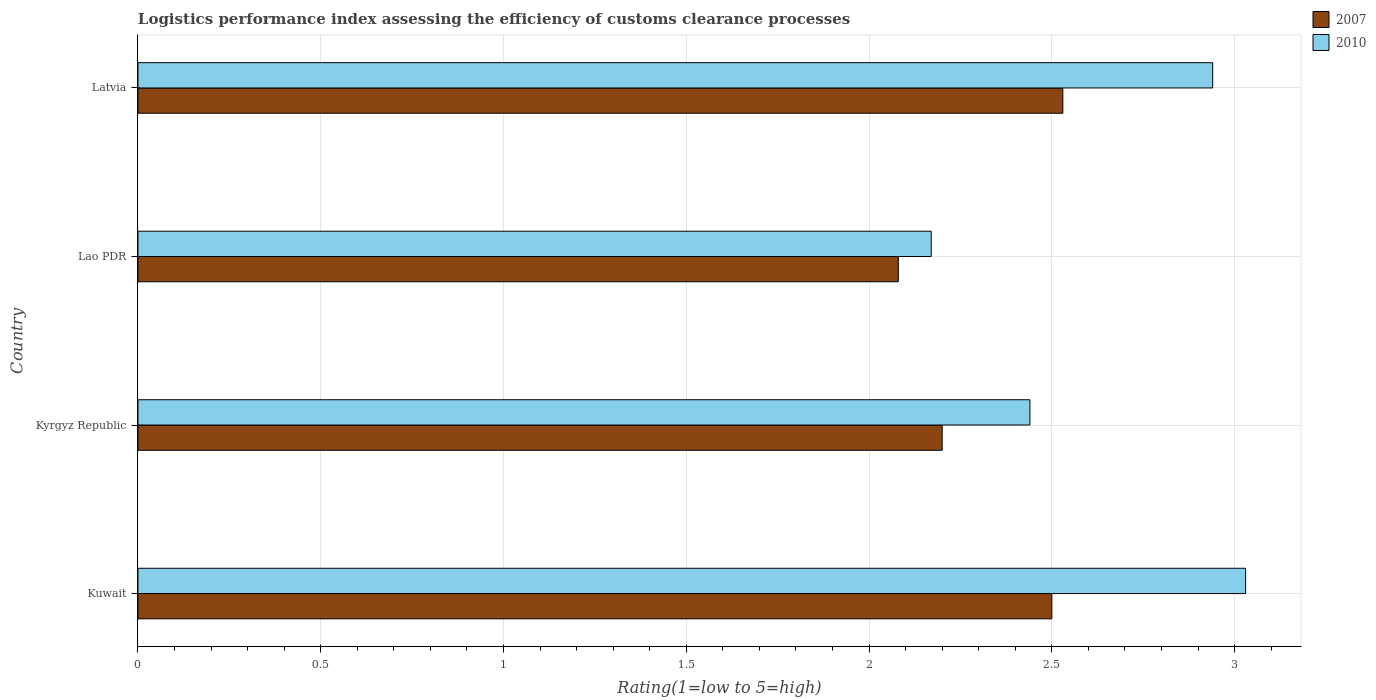How many groups of bars are there?
Offer a very short reply. 4. What is the label of the 4th group of bars from the top?
Make the answer very short. Kuwait. In how many cases, is the number of bars for a given country not equal to the number of legend labels?
Provide a short and direct response. 0. What is the Logistic performance index in 2010 in Kyrgyz Republic?
Your response must be concise. 2.44. Across all countries, what is the maximum Logistic performance index in 2007?
Ensure brevity in your answer.  2.53. Across all countries, what is the minimum Logistic performance index in 2010?
Offer a very short reply. 2.17. In which country was the Logistic performance index in 2010 maximum?
Offer a terse response. Kuwait. In which country was the Logistic performance index in 2007 minimum?
Your response must be concise. Lao PDR. What is the total Logistic performance index in 2007 in the graph?
Make the answer very short. 9.31. What is the difference between the Logistic performance index in 2007 in Lao PDR and that in Latvia?
Offer a very short reply. -0.45. What is the difference between the Logistic performance index in 2010 in Kyrgyz Republic and the Logistic performance index in 2007 in Lao PDR?
Give a very brief answer. 0.36. What is the average Logistic performance index in 2007 per country?
Your response must be concise. 2.33. What is the difference between the Logistic performance index in 2010 and Logistic performance index in 2007 in Kyrgyz Republic?
Offer a very short reply. 0.24. What is the ratio of the Logistic performance index in 2007 in Kyrgyz Republic to that in Latvia?
Your answer should be compact. 0.87. Is the Logistic performance index in 2010 in Kuwait less than that in Kyrgyz Republic?
Offer a very short reply. No. Is the difference between the Logistic performance index in 2010 in Kuwait and Kyrgyz Republic greater than the difference between the Logistic performance index in 2007 in Kuwait and Kyrgyz Republic?
Provide a short and direct response. Yes. What is the difference between the highest and the second highest Logistic performance index in 2010?
Keep it short and to the point. 0.09. What is the difference between the highest and the lowest Logistic performance index in 2007?
Provide a short and direct response. 0.45. What does the 2nd bar from the top in Latvia represents?
Ensure brevity in your answer.  2007. How many bars are there?
Provide a short and direct response. 8. How many countries are there in the graph?
Offer a very short reply. 4. What is the difference between two consecutive major ticks on the X-axis?
Make the answer very short. 0.5. Does the graph contain any zero values?
Provide a succinct answer. No. Does the graph contain grids?
Your answer should be very brief. Yes. What is the title of the graph?
Your answer should be compact. Logistics performance index assessing the efficiency of customs clearance processes. What is the label or title of the X-axis?
Your answer should be very brief. Rating(1=low to 5=high). What is the Rating(1=low to 5=high) of 2007 in Kuwait?
Your answer should be compact. 2.5. What is the Rating(1=low to 5=high) in 2010 in Kuwait?
Give a very brief answer. 3.03. What is the Rating(1=low to 5=high) of 2010 in Kyrgyz Republic?
Offer a very short reply. 2.44. What is the Rating(1=low to 5=high) in 2007 in Lao PDR?
Provide a short and direct response. 2.08. What is the Rating(1=low to 5=high) in 2010 in Lao PDR?
Provide a short and direct response. 2.17. What is the Rating(1=low to 5=high) in 2007 in Latvia?
Your answer should be compact. 2.53. What is the Rating(1=low to 5=high) in 2010 in Latvia?
Your answer should be compact. 2.94. Across all countries, what is the maximum Rating(1=low to 5=high) in 2007?
Offer a very short reply. 2.53. Across all countries, what is the maximum Rating(1=low to 5=high) of 2010?
Offer a terse response. 3.03. Across all countries, what is the minimum Rating(1=low to 5=high) in 2007?
Offer a terse response. 2.08. Across all countries, what is the minimum Rating(1=low to 5=high) of 2010?
Offer a very short reply. 2.17. What is the total Rating(1=low to 5=high) in 2007 in the graph?
Offer a terse response. 9.31. What is the total Rating(1=low to 5=high) in 2010 in the graph?
Your answer should be compact. 10.58. What is the difference between the Rating(1=low to 5=high) of 2007 in Kuwait and that in Kyrgyz Republic?
Provide a short and direct response. 0.3. What is the difference between the Rating(1=low to 5=high) of 2010 in Kuwait and that in Kyrgyz Republic?
Your answer should be compact. 0.59. What is the difference between the Rating(1=low to 5=high) of 2007 in Kuwait and that in Lao PDR?
Offer a very short reply. 0.42. What is the difference between the Rating(1=low to 5=high) of 2010 in Kuwait and that in Lao PDR?
Ensure brevity in your answer.  0.86. What is the difference between the Rating(1=low to 5=high) of 2007 in Kuwait and that in Latvia?
Your response must be concise. -0.03. What is the difference between the Rating(1=low to 5=high) of 2010 in Kuwait and that in Latvia?
Your answer should be compact. 0.09. What is the difference between the Rating(1=low to 5=high) of 2007 in Kyrgyz Republic and that in Lao PDR?
Your answer should be very brief. 0.12. What is the difference between the Rating(1=low to 5=high) of 2010 in Kyrgyz Republic and that in Lao PDR?
Make the answer very short. 0.27. What is the difference between the Rating(1=low to 5=high) in 2007 in Kyrgyz Republic and that in Latvia?
Make the answer very short. -0.33. What is the difference between the Rating(1=low to 5=high) of 2007 in Lao PDR and that in Latvia?
Ensure brevity in your answer.  -0.45. What is the difference between the Rating(1=low to 5=high) of 2010 in Lao PDR and that in Latvia?
Give a very brief answer. -0.77. What is the difference between the Rating(1=low to 5=high) in 2007 in Kuwait and the Rating(1=low to 5=high) in 2010 in Kyrgyz Republic?
Make the answer very short. 0.06. What is the difference between the Rating(1=low to 5=high) in 2007 in Kuwait and the Rating(1=low to 5=high) in 2010 in Lao PDR?
Offer a very short reply. 0.33. What is the difference between the Rating(1=low to 5=high) of 2007 in Kuwait and the Rating(1=low to 5=high) of 2010 in Latvia?
Provide a succinct answer. -0.44. What is the difference between the Rating(1=low to 5=high) of 2007 in Kyrgyz Republic and the Rating(1=low to 5=high) of 2010 in Latvia?
Offer a very short reply. -0.74. What is the difference between the Rating(1=low to 5=high) in 2007 in Lao PDR and the Rating(1=low to 5=high) in 2010 in Latvia?
Provide a short and direct response. -0.86. What is the average Rating(1=low to 5=high) of 2007 per country?
Your answer should be very brief. 2.33. What is the average Rating(1=low to 5=high) in 2010 per country?
Your response must be concise. 2.65. What is the difference between the Rating(1=low to 5=high) of 2007 and Rating(1=low to 5=high) of 2010 in Kuwait?
Make the answer very short. -0.53. What is the difference between the Rating(1=low to 5=high) in 2007 and Rating(1=low to 5=high) in 2010 in Kyrgyz Republic?
Provide a succinct answer. -0.24. What is the difference between the Rating(1=low to 5=high) in 2007 and Rating(1=low to 5=high) in 2010 in Lao PDR?
Keep it short and to the point. -0.09. What is the difference between the Rating(1=low to 5=high) of 2007 and Rating(1=low to 5=high) of 2010 in Latvia?
Offer a terse response. -0.41. What is the ratio of the Rating(1=low to 5=high) of 2007 in Kuwait to that in Kyrgyz Republic?
Provide a succinct answer. 1.14. What is the ratio of the Rating(1=low to 5=high) in 2010 in Kuwait to that in Kyrgyz Republic?
Your answer should be very brief. 1.24. What is the ratio of the Rating(1=low to 5=high) of 2007 in Kuwait to that in Lao PDR?
Provide a succinct answer. 1.2. What is the ratio of the Rating(1=low to 5=high) in 2010 in Kuwait to that in Lao PDR?
Provide a short and direct response. 1.4. What is the ratio of the Rating(1=low to 5=high) of 2007 in Kuwait to that in Latvia?
Offer a terse response. 0.99. What is the ratio of the Rating(1=low to 5=high) of 2010 in Kuwait to that in Latvia?
Your answer should be very brief. 1.03. What is the ratio of the Rating(1=low to 5=high) in 2007 in Kyrgyz Republic to that in Lao PDR?
Your response must be concise. 1.06. What is the ratio of the Rating(1=low to 5=high) in 2010 in Kyrgyz Republic to that in Lao PDR?
Offer a terse response. 1.12. What is the ratio of the Rating(1=low to 5=high) in 2007 in Kyrgyz Republic to that in Latvia?
Your response must be concise. 0.87. What is the ratio of the Rating(1=low to 5=high) of 2010 in Kyrgyz Republic to that in Latvia?
Keep it short and to the point. 0.83. What is the ratio of the Rating(1=low to 5=high) in 2007 in Lao PDR to that in Latvia?
Offer a very short reply. 0.82. What is the ratio of the Rating(1=low to 5=high) of 2010 in Lao PDR to that in Latvia?
Ensure brevity in your answer.  0.74. What is the difference between the highest and the second highest Rating(1=low to 5=high) of 2010?
Your answer should be compact. 0.09. What is the difference between the highest and the lowest Rating(1=low to 5=high) of 2007?
Your response must be concise. 0.45. What is the difference between the highest and the lowest Rating(1=low to 5=high) in 2010?
Offer a very short reply. 0.86. 